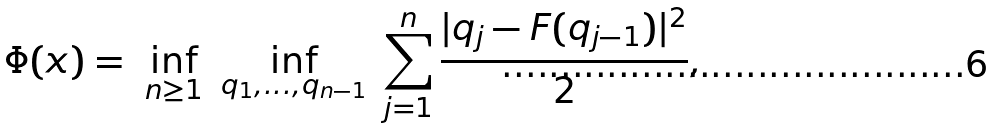Convert formula to latex. <formula><loc_0><loc_0><loc_500><loc_500>\Phi ( x ) = \ \inf _ { n \geq 1 } \ \inf _ { q _ { 1 } , \dots , q _ { n - 1 } } \ \sum _ { j = 1 } ^ { n } \frac { | q _ { j } - F ( q _ { j - 1 } ) | ^ { 2 } } { 2 } ,</formula> 